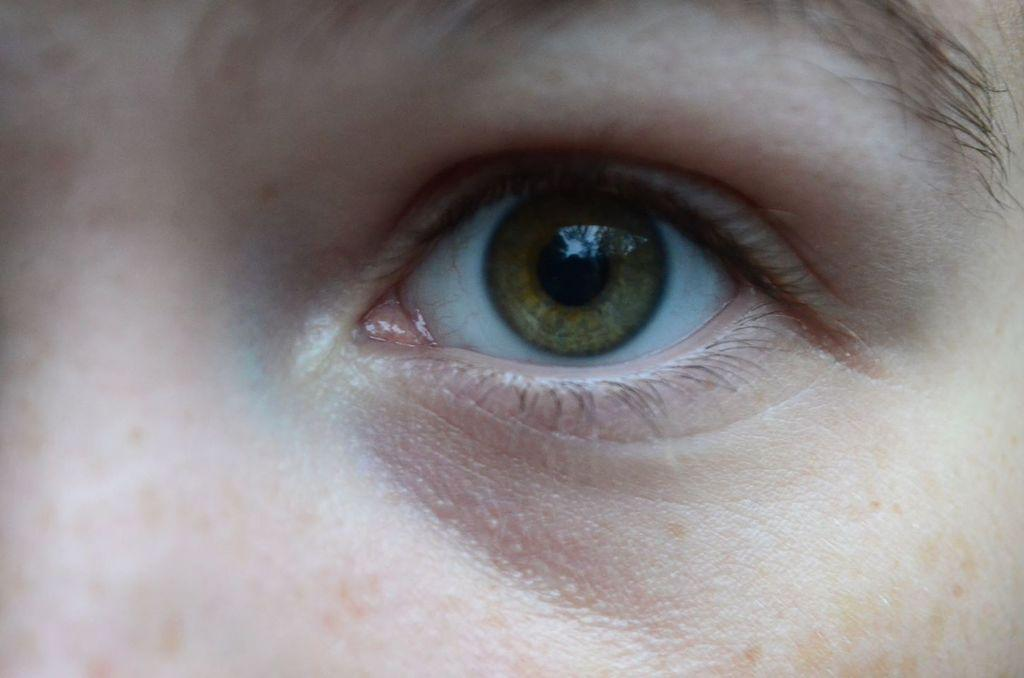What part of the human body is the main focus of the image? The main focus of the image is a person's eye. What other facial feature is visible in the image? A person's eyebrow is also visible in the image. What word is being spelled out by the person's eye in the image? There is no word being spelled out by the person's eye in the image, as it is a photograph of a person's eye and not a text-based image. 